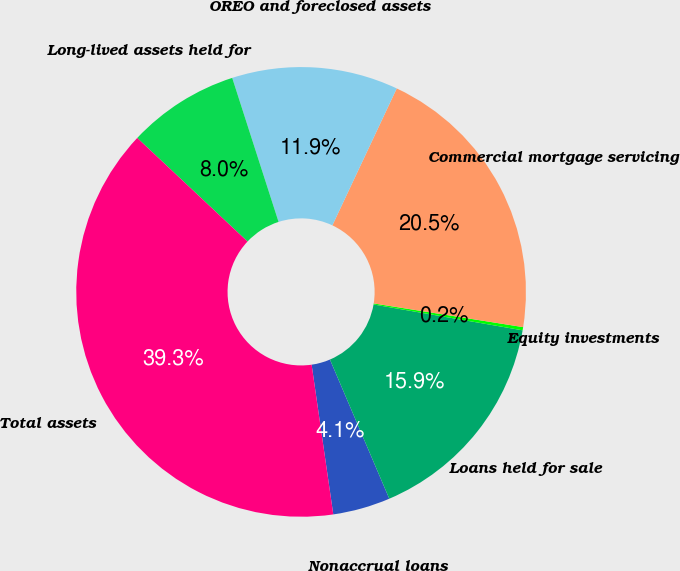Convert chart to OTSL. <chart><loc_0><loc_0><loc_500><loc_500><pie_chart><fcel>Nonaccrual loans<fcel>Loans held for sale<fcel>Equity investments<fcel>Commercial mortgage servicing<fcel>OREO and foreclosed assets<fcel>Long-lived assets held for<fcel>Total assets<nl><fcel>4.13%<fcel>15.85%<fcel>0.23%<fcel>20.51%<fcel>11.95%<fcel>8.04%<fcel>39.29%<nl></chart> 